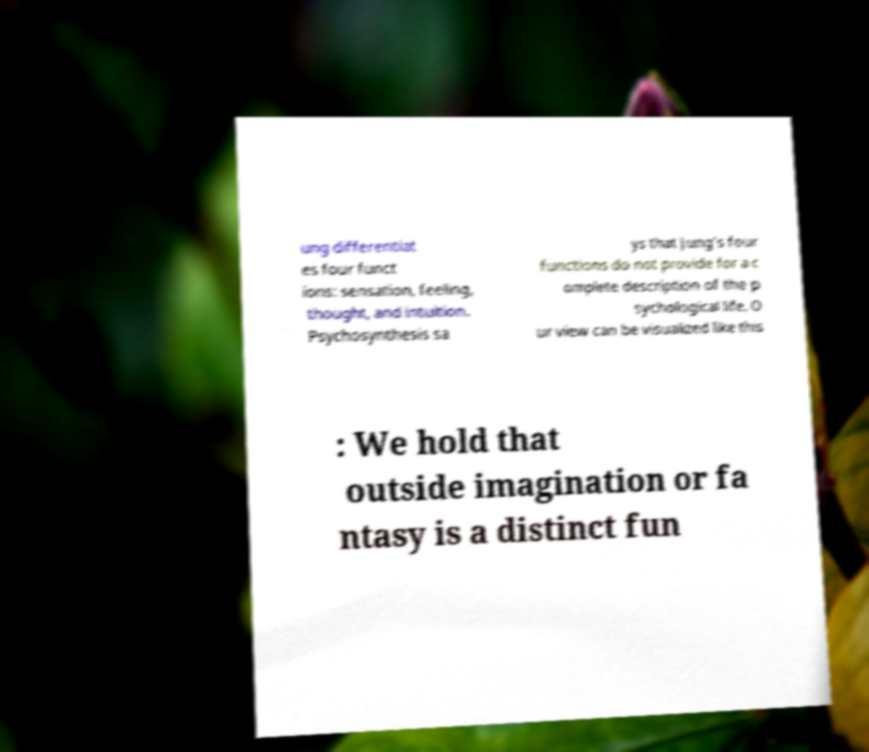I need the written content from this picture converted into text. Can you do that? ung differentiat es four funct ions: sensation, feeling, thought, and intuition. Psychosynthesis sa ys that Jung’s four functions do not provide for a c omplete description of the p sychological life. O ur view can be visualized like this : We hold that outside imagination or fa ntasy is a distinct fun 